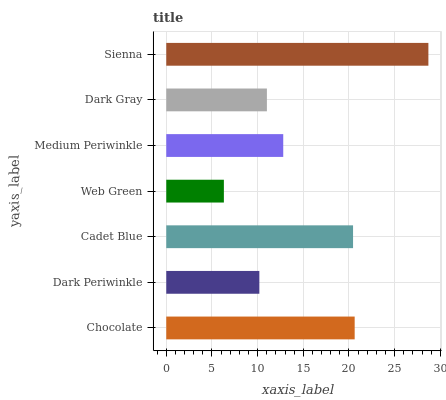Is Web Green the minimum?
Answer yes or no. Yes. Is Sienna the maximum?
Answer yes or no. Yes. Is Dark Periwinkle the minimum?
Answer yes or no. No. Is Dark Periwinkle the maximum?
Answer yes or no. No. Is Chocolate greater than Dark Periwinkle?
Answer yes or no. Yes. Is Dark Periwinkle less than Chocolate?
Answer yes or no. Yes. Is Dark Periwinkle greater than Chocolate?
Answer yes or no. No. Is Chocolate less than Dark Periwinkle?
Answer yes or no. No. Is Medium Periwinkle the high median?
Answer yes or no. Yes. Is Medium Periwinkle the low median?
Answer yes or no. Yes. Is Sienna the high median?
Answer yes or no. No. Is Web Green the low median?
Answer yes or no. No. 